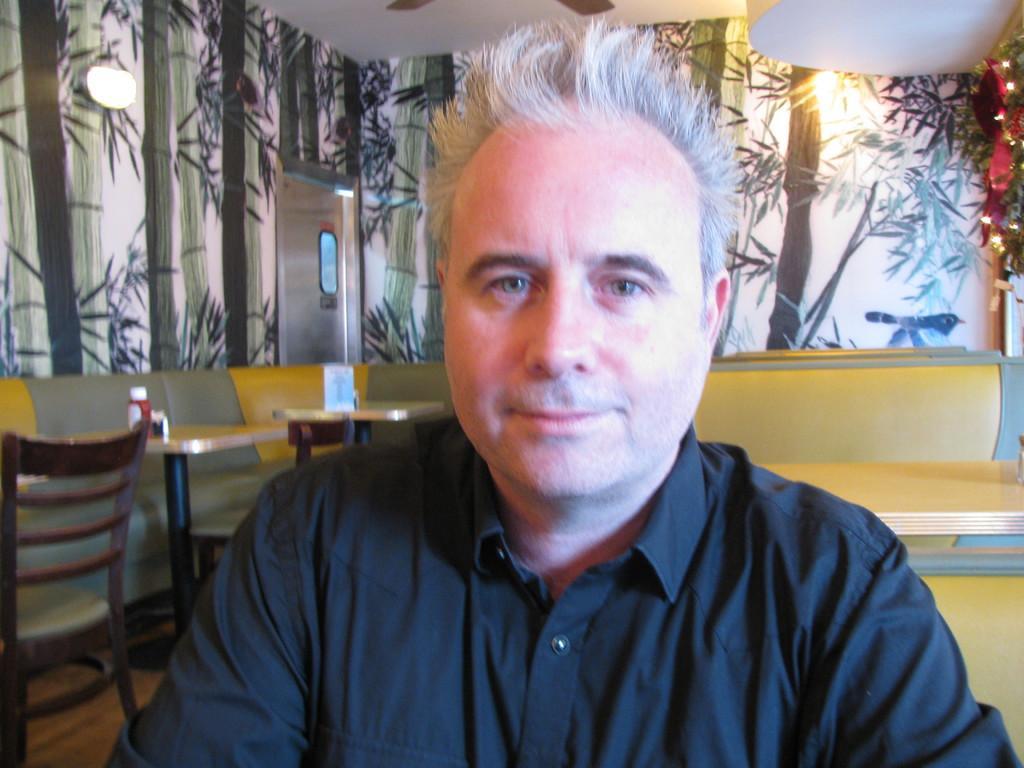Could you give a brief overview of what you see in this image? In this image there are chairs, tables with objects, there is a light, there is a painting on the wall on the left corner. There is a person in the foreground. There are tables, chairs, on the right corner. There is a painting on the wall in the background. And there is roof at the top. 